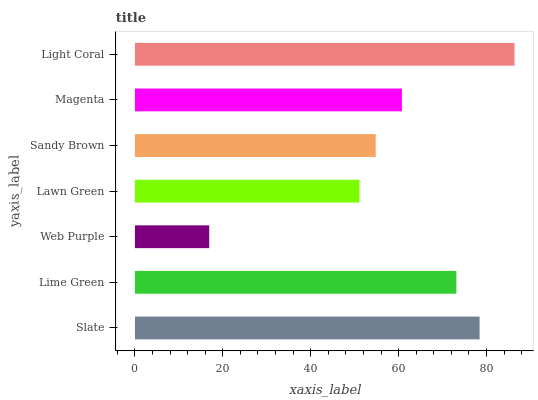Is Web Purple the minimum?
Answer yes or no. Yes. Is Light Coral the maximum?
Answer yes or no. Yes. Is Lime Green the minimum?
Answer yes or no. No. Is Lime Green the maximum?
Answer yes or no. No. Is Slate greater than Lime Green?
Answer yes or no. Yes. Is Lime Green less than Slate?
Answer yes or no. Yes. Is Lime Green greater than Slate?
Answer yes or no. No. Is Slate less than Lime Green?
Answer yes or no. No. Is Magenta the high median?
Answer yes or no. Yes. Is Magenta the low median?
Answer yes or no. Yes. Is Lime Green the high median?
Answer yes or no. No. Is Lime Green the low median?
Answer yes or no. No. 